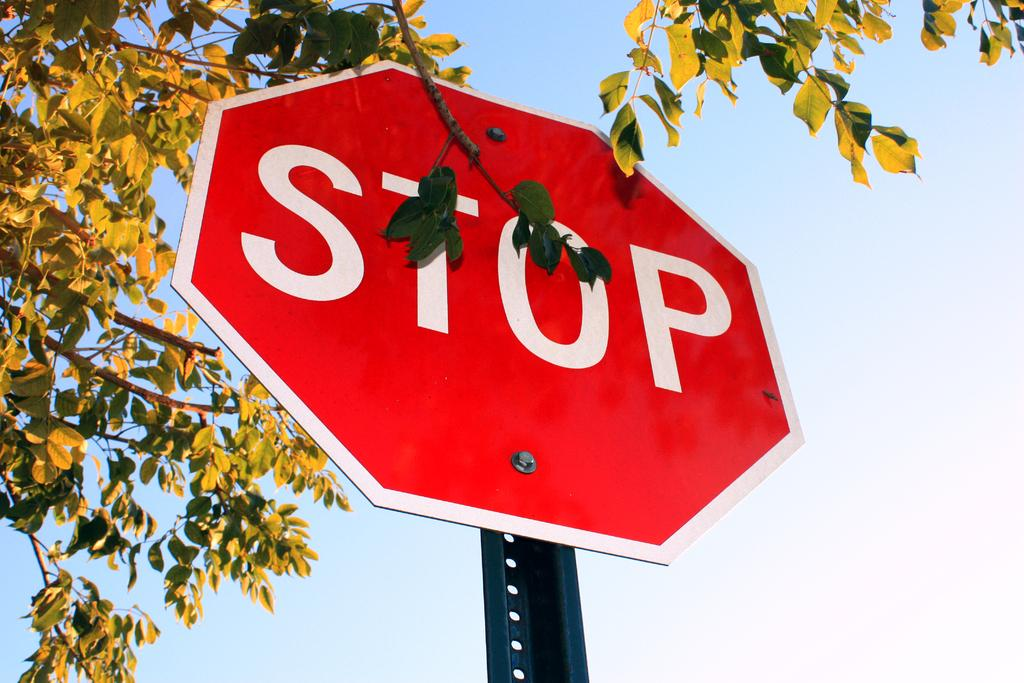What is on the pole in the image? There is a sign board on a pole in the image. What type of vegetation can be seen in the image? There are green leaves and stems in the image. What can be seen in the background of the image? The sky is visible in the background of the image. How many frogs are sitting on the sign board in the image? There are no frogs present in the image; it only features a sign board on a pole and green leaves and stems. 